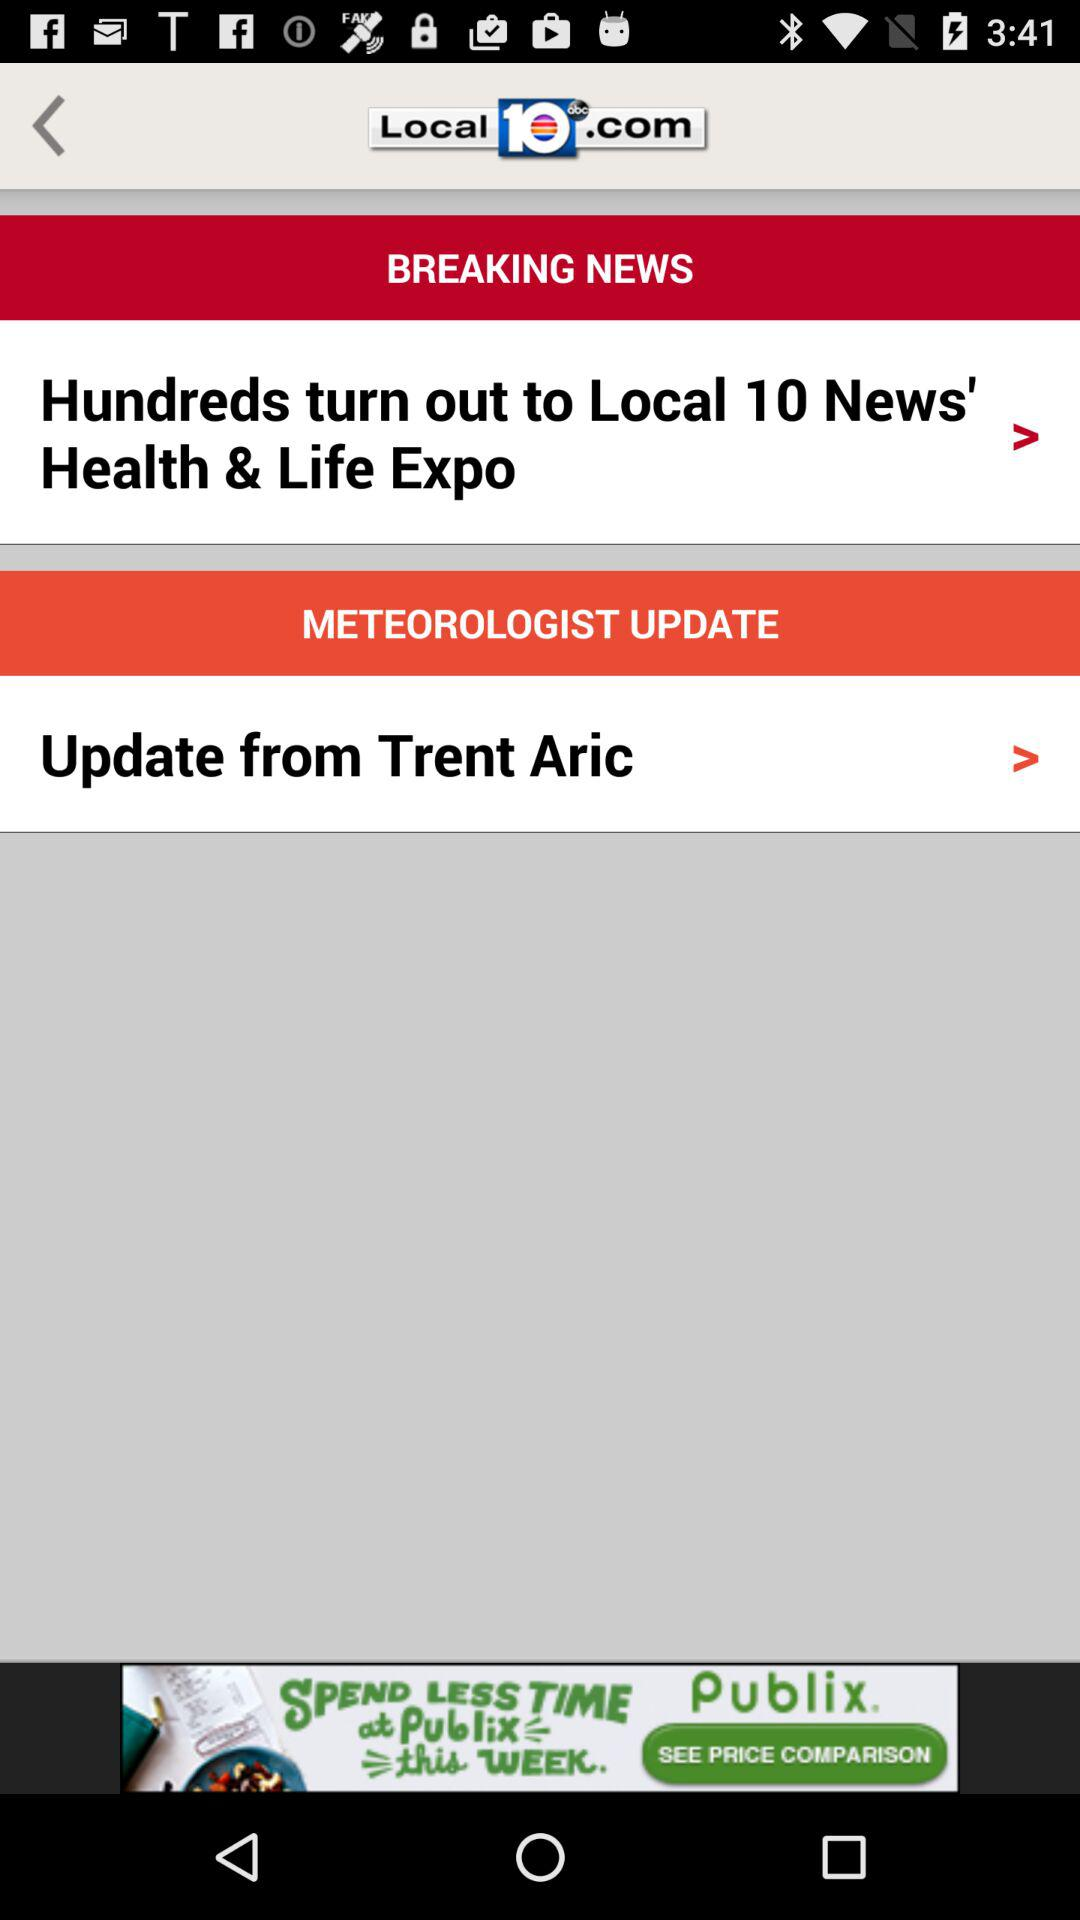What is the name of the application? The name of the application is "Local 10". 